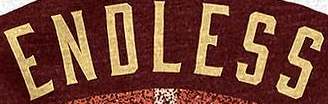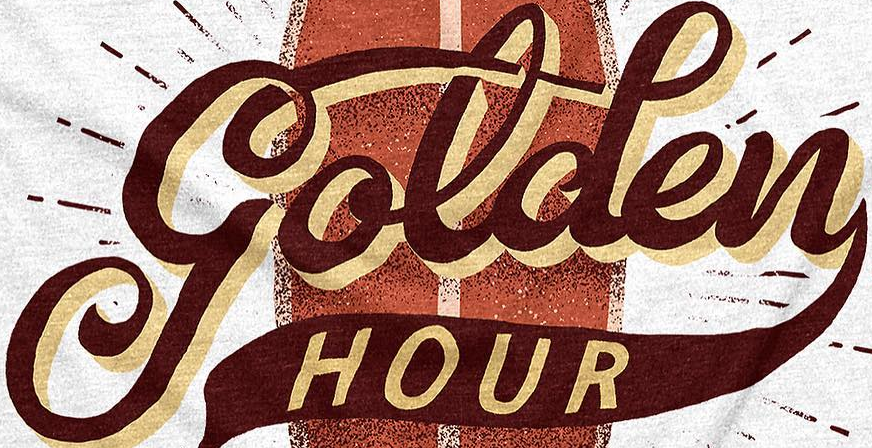Read the text content from these images in order, separated by a semicolon. ENDLESS; golden 